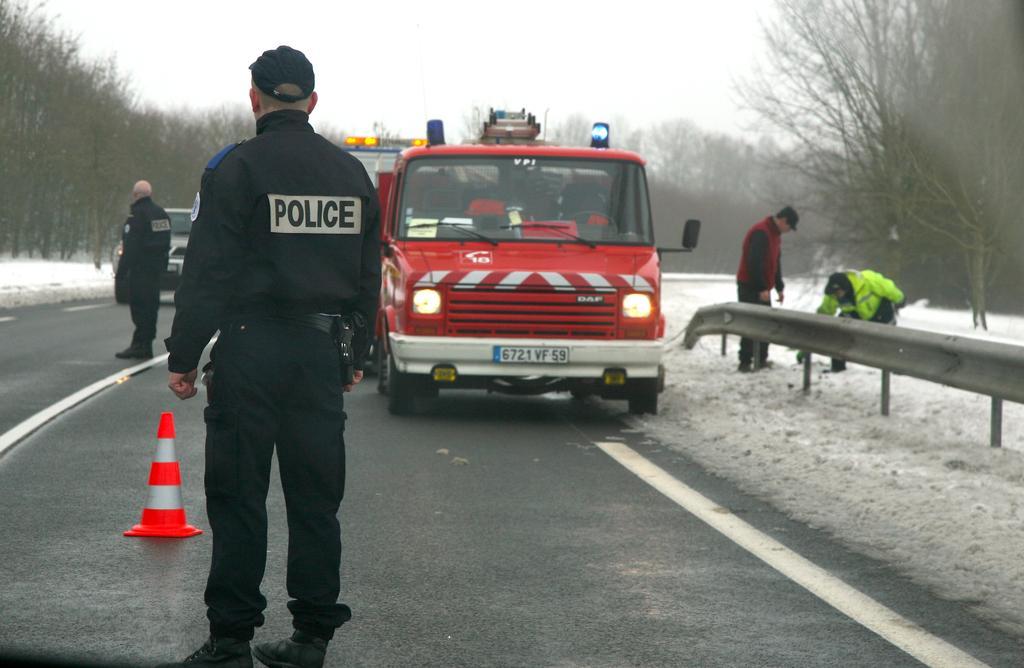Please provide a concise description of this image. There is a police vehicle and around the vehicle there are four police two of them are in the right side of the vehicle and remaining two are standing on the road in the left side of the vehicle and around the road there are plenty of dry trees and snow. 